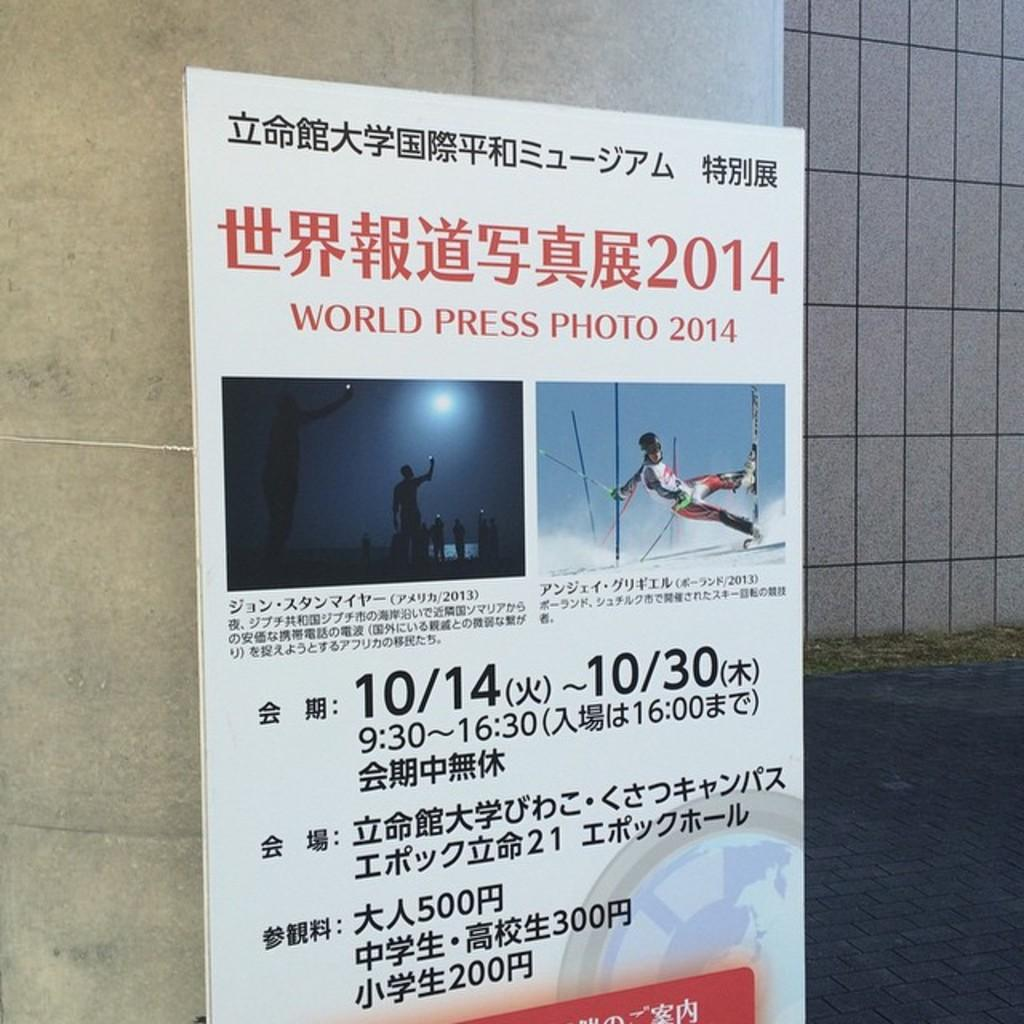<image>
Write a terse but informative summary of the picture. a sign that has the world press photo on it 